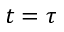Convert formula to latex. <formula><loc_0><loc_0><loc_500><loc_500>t = \tau</formula> 